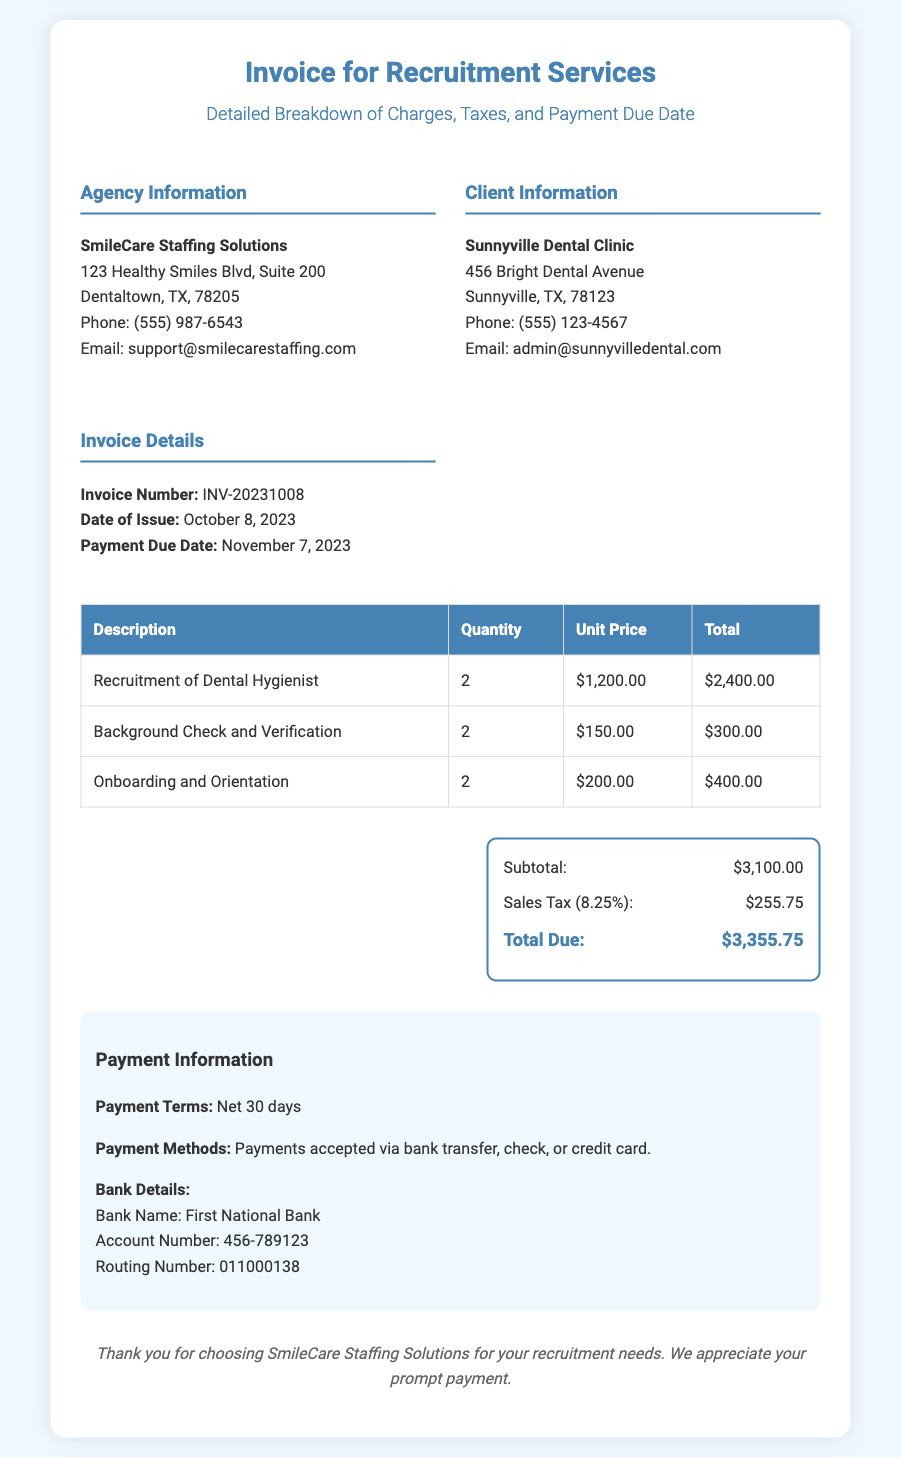what is the agency name? The agency name is stated at the top section in bold text.
Answer: SmileCare Staffing Solutions what is the invoice number? The invoice number is clearly listed under the Invoice Details section.
Answer: INV-20231008 when is the payment due date? The payment due date can be found in the Invoice Details section.
Answer: November 7, 2023 how many dental hygienists were recruited? The number of dental hygienists recruited can be calculated from the Recruitment of Dental Hygienist line item.
Answer: 2 what is the total due amount? The total due amount is at the bottom of the total section of the invoice.
Answer: $3,355.75 what is the sales tax percentage applied? The sales tax percentage is noted in the total section as a percentage.
Answer: 8.25% what payment methods are accepted? The payment methods are listed in the Payment Information section.
Answer: bank transfer, check, or credit card what is the subtotal amount? The subtotal amount is mentioned before the sales tax in the total section.
Answer: $3,100.00 what is the address of the client? The address of the client is outlined in the Client Information section.
Answer: 456 Bright Dental Avenue, Sunnyville, TX, 78123 